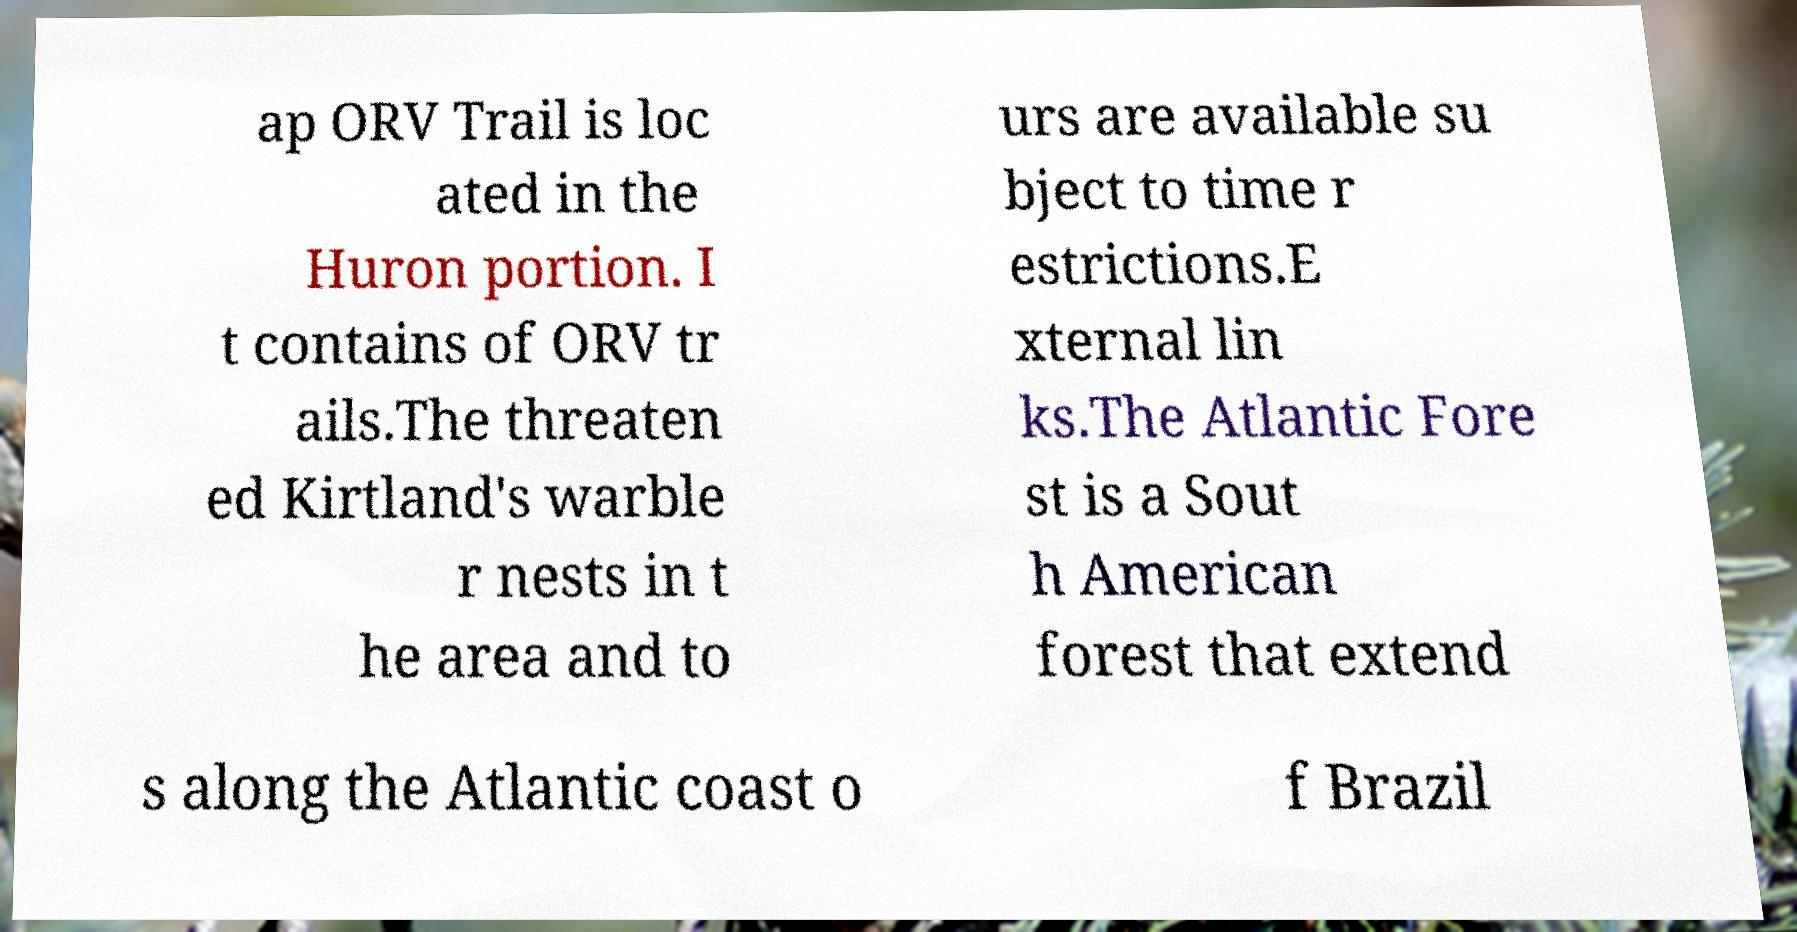What messages or text are displayed in this image? I need them in a readable, typed format. ap ORV Trail is loc ated in the Huron portion. I t contains of ORV tr ails.The threaten ed Kirtland's warble r nests in t he area and to urs are available su bject to time r estrictions.E xternal lin ks.The Atlantic Fore st is a Sout h American forest that extend s along the Atlantic coast o f Brazil 